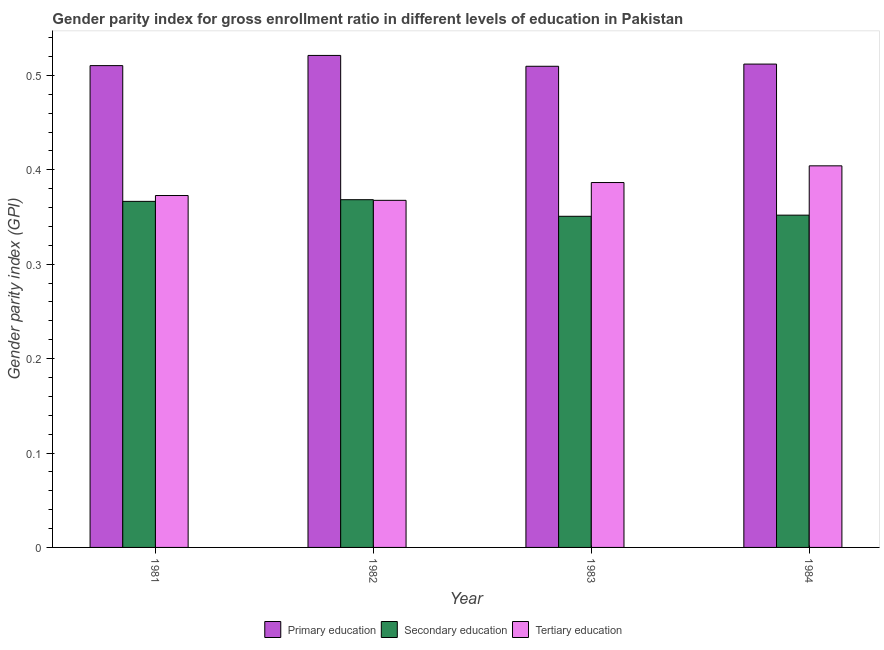What is the gender parity index in tertiary education in 1982?
Ensure brevity in your answer.  0.37. Across all years, what is the maximum gender parity index in secondary education?
Offer a very short reply. 0.37. Across all years, what is the minimum gender parity index in secondary education?
Your response must be concise. 0.35. What is the total gender parity index in primary education in the graph?
Offer a very short reply. 2.05. What is the difference between the gender parity index in secondary education in 1981 and that in 1982?
Make the answer very short. -0. What is the difference between the gender parity index in primary education in 1983 and the gender parity index in tertiary education in 1984?
Give a very brief answer. -0. What is the average gender parity index in tertiary education per year?
Your answer should be very brief. 0.38. In the year 1982, what is the difference between the gender parity index in tertiary education and gender parity index in primary education?
Your answer should be very brief. 0. In how many years, is the gender parity index in secondary education greater than 0.24000000000000002?
Provide a succinct answer. 4. What is the ratio of the gender parity index in primary education in 1981 to that in 1983?
Make the answer very short. 1. Is the difference between the gender parity index in tertiary education in 1983 and 1984 greater than the difference between the gender parity index in primary education in 1983 and 1984?
Keep it short and to the point. No. What is the difference between the highest and the second highest gender parity index in tertiary education?
Your answer should be very brief. 0.02. What is the difference between the highest and the lowest gender parity index in primary education?
Your response must be concise. 0.01. What does the 2nd bar from the left in 1981 represents?
Ensure brevity in your answer.  Secondary education. What does the 2nd bar from the right in 1982 represents?
Give a very brief answer. Secondary education. Are all the bars in the graph horizontal?
Your answer should be very brief. No. Does the graph contain any zero values?
Provide a short and direct response. No. Does the graph contain grids?
Make the answer very short. No. Where does the legend appear in the graph?
Provide a succinct answer. Bottom center. How many legend labels are there?
Your answer should be compact. 3. What is the title of the graph?
Give a very brief answer. Gender parity index for gross enrollment ratio in different levels of education in Pakistan. Does "Transport services" appear as one of the legend labels in the graph?
Keep it short and to the point. No. What is the label or title of the X-axis?
Your answer should be compact. Year. What is the label or title of the Y-axis?
Offer a terse response. Gender parity index (GPI). What is the Gender parity index (GPI) in Primary education in 1981?
Give a very brief answer. 0.51. What is the Gender parity index (GPI) in Secondary education in 1981?
Keep it short and to the point. 0.37. What is the Gender parity index (GPI) of Tertiary education in 1981?
Offer a terse response. 0.37. What is the Gender parity index (GPI) in Primary education in 1982?
Your answer should be very brief. 0.52. What is the Gender parity index (GPI) of Secondary education in 1982?
Your answer should be compact. 0.37. What is the Gender parity index (GPI) in Tertiary education in 1982?
Ensure brevity in your answer.  0.37. What is the Gender parity index (GPI) in Primary education in 1983?
Make the answer very short. 0.51. What is the Gender parity index (GPI) in Secondary education in 1983?
Keep it short and to the point. 0.35. What is the Gender parity index (GPI) of Tertiary education in 1983?
Offer a terse response. 0.39. What is the Gender parity index (GPI) of Primary education in 1984?
Ensure brevity in your answer.  0.51. What is the Gender parity index (GPI) in Secondary education in 1984?
Make the answer very short. 0.35. What is the Gender parity index (GPI) in Tertiary education in 1984?
Keep it short and to the point. 0.4. Across all years, what is the maximum Gender parity index (GPI) in Primary education?
Give a very brief answer. 0.52. Across all years, what is the maximum Gender parity index (GPI) of Secondary education?
Provide a succinct answer. 0.37. Across all years, what is the maximum Gender parity index (GPI) in Tertiary education?
Offer a terse response. 0.4. Across all years, what is the minimum Gender parity index (GPI) of Primary education?
Make the answer very short. 0.51. Across all years, what is the minimum Gender parity index (GPI) in Secondary education?
Your answer should be compact. 0.35. Across all years, what is the minimum Gender parity index (GPI) in Tertiary education?
Offer a terse response. 0.37. What is the total Gender parity index (GPI) of Primary education in the graph?
Your answer should be very brief. 2.05. What is the total Gender parity index (GPI) of Secondary education in the graph?
Your response must be concise. 1.44. What is the total Gender parity index (GPI) of Tertiary education in the graph?
Provide a short and direct response. 1.53. What is the difference between the Gender parity index (GPI) in Primary education in 1981 and that in 1982?
Your answer should be compact. -0.01. What is the difference between the Gender parity index (GPI) in Secondary education in 1981 and that in 1982?
Make the answer very short. -0. What is the difference between the Gender parity index (GPI) in Tertiary education in 1981 and that in 1982?
Give a very brief answer. 0.01. What is the difference between the Gender parity index (GPI) of Primary education in 1981 and that in 1983?
Ensure brevity in your answer.  0. What is the difference between the Gender parity index (GPI) of Secondary education in 1981 and that in 1983?
Make the answer very short. 0.02. What is the difference between the Gender parity index (GPI) of Tertiary education in 1981 and that in 1983?
Make the answer very short. -0.01. What is the difference between the Gender parity index (GPI) of Primary education in 1981 and that in 1984?
Ensure brevity in your answer.  -0. What is the difference between the Gender parity index (GPI) of Secondary education in 1981 and that in 1984?
Your answer should be very brief. 0.01. What is the difference between the Gender parity index (GPI) of Tertiary education in 1981 and that in 1984?
Give a very brief answer. -0.03. What is the difference between the Gender parity index (GPI) in Primary education in 1982 and that in 1983?
Make the answer very short. 0.01. What is the difference between the Gender parity index (GPI) in Secondary education in 1982 and that in 1983?
Provide a short and direct response. 0.02. What is the difference between the Gender parity index (GPI) in Tertiary education in 1982 and that in 1983?
Make the answer very short. -0.02. What is the difference between the Gender parity index (GPI) of Primary education in 1982 and that in 1984?
Ensure brevity in your answer.  0.01. What is the difference between the Gender parity index (GPI) in Secondary education in 1982 and that in 1984?
Offer a very short reply. 0.02. What is the difference between the Gender parity index (GPI) of Tertiary education in 1982 and that in 1984?
Ensure brevity in your answer.  -0.04. What is the difference between the Gender parity index (GPI) in Primary education in 1983 and that in 1984?
Offer a very short reply. -0. What is the difference between the Gender parity index (GPI) of Secondary education in 1983 and that in 1984?
Make the answer very short. -0. What is the difference between the Gender parity index (GPI) of Tertiary education in 1983 and that in 1984?
Provide a short and direct response. -0.02. What is the difference between the Gender parity index (GPI) of Primary education in 1981 and the Gender parity index (GPI) of Secondary education in 1982?
Provide a short and direct response. 0.14. What is the difference between the Gender parity index (GPI) of Primary education in 1981 and the Gender parity index (GPI) of Tertiary education in 1982?
Provide a short and direct response. 0.14. What is the difference between the Gender parity index (GPI) in Secondary education in 1981 and the Gender parity index (GPI) in Tertiary education in 1982?
Provide a succinct answer. -0. What is the difference between the Gender parity index (GPI) in Primary education in 1981 and the Gender parity index (GPI) in Secondary education in 1983?
Provide a short and direct response. 0.16. What is the difference between the Gender parity index (GPI) in Primary education in 1981 and the Gender parity index (GPI) in Tertiary education in 1983?
Offer a very short reply. 0.12. What is the difference between the Gender parity index (GPI) in Secondary education in 1981 and the Gender parity index (GPI) in Tertiary education in 1983?
Keep it short and to the point. -0.02. What is the difference between the Gender parity index (GPI) of Primary education in 1981 and the Gender parity index (GPI) of Secondary education in 1984?
Offer a terse response. 0.16. What is the difference between the Gender parity index (GPI) of Primary education in 1981 and the Gender parity index (GPI) of Tertiary education in 1984?
Offer a very short reply. 0.11. What is the difference between the Gender parity index (GPI) of Secondary education in 1981 and the Gender parity index (GPI) of Tertiary education in 1984?
Keep it short and to the point. -0.04. What is the difference between the Gender parity index (GPI) in Primary education in 1982 and the Gender parity index (GPI) in Secondary education in 1983?
Your response must be concise. 0.17. What is the difference between the Gender parity index (GPI) of Primary education in 1982 and the Gender parity index (GPI) of Tertiary education in 1983?
Give a very brief answer. 0.13. What is the difference between the Gender parity index (GPI) of Secondary education in 1982 and the Gender parity index (GPI) of Tertiary education in 1983?
Give a very brief answer. -0.02. What is the difference between the Gender parity index (GPI) in Primary education in 1982 and the Gender parity index (GPI) in Secondary education in 1984?
Your response must be concise. 0.17. What is the difference between the Gender parity index (GPI) of Primary education in 1982 and the Gender parity index (GPI) of Tertiary education in 1984?
Provide a short and direct response. 0.12. What is the difference between the Gender parity index (GPI) in Secondary education in 1982 and the Gender parity index (GPI) in Tertiary education in 1984?
Give a very brief answer. -0.04. What is the difference between the Gender parity index (GPI) in Primary education in 1983 and the Gender parity index (GPI) in Secondary education in 1984?
Provide a short and direct response. 0.16. What is the difference between the Gender parity index (GPI) in Primary education in 1983 and the Gender parity index (GPI) in Tertiary education in 1984?
Your response must be concise. 0.11. What is the difference between the Gender parity index (GPI) in Secondary education in 1983 and the Gender parity index (GPI) in Tertiary education in 1984?
Your response must be concise. -0.05. What is the average Gender parity index (GPI) of Primary education per year?
Keep it short and to the point. 0.51. What is the average Gender parity index (GPI) in Secondary education per year?
Provide a succinct answer. 0.36. What is the average Gender parity index (GPI) in Tertiary education per year?
Your answer should be compact. 0.38. In the year 1981, what is the difference between the Gender parity index (GPI) in Primary education and Gender parity index (GPI) in Secondary education?
Your answer should be very brief. 0.14. In the year 1981, what is the difference between the Gender parity index (GPI) of Primary education and Gender parity index (GPI) of Tertiary education?
Provide a short and direct response. 0.14. In the year 1981, what is the difference between the Gender parity index (GPI) in Secondary education and Gender parity index (GPI) in Tertiary education?
Offer a terse response. -0.01. In the year 1982, what is the difference between the Gender parity index (GPI) in Primary education and Gender parity index (GPI) in Secondary education?
Make the answer very short. 0.15. In the year 1982, what is the difference between the Gender parity index (GPI) of Primary education and Gender parity index (GPI) of Tertiary education?
Make the answer very short. 0.15. In the year 1982, what is the difference between the Gender parity index (GPI) in Secondary education and Gender parity index (GPI) in Tertiary education?
Provide a succinct answer. 0. In the year 1983, what is the difference between the Gender parity index (GPI) in Primary education and Gender parity index (GPI) in Secondary education?
Offer a very short reply. 0.16. In the year 1983, what is the difference between the Gender parity index (GPI) in Primary education and Gender parity index (GPI) in Tertiary education?
Make the answer very short. 0.12. In the year 1983, what is the difference between the Gender parity index (GPI) of Secondary education and Gender parity index (GPI) of Tertiary education?
Your answer should be compact. -0.04. In the year 1984, what is the difference between the Gender parity index (GPI) in Primary education and Gender parity index (GPI) in Secondary education?
Provide a succinct answer. 0.16. In the year 1984, what is the difference between the Gender parity index (GPI) of Primary education and Gender parity index (GPI) of Tertiary education?
Make the answer very short. 0.11. In the year 1984, what is the difference between the Gender parity index (GPI) in Secondary education and Gender parity index (GPI) in Tertiary education?
Your answer should be compact. -0.05. What is the ratio of the Gender parity index (GPI) in Primary education in 1981 to that in 1982?
Your answer should be very brief. 0.98. What is the ratio of the Gender parity index (GPI) in Secondary education in 1981 to that in 1982?
Provide a succinct answer. 1. What is the ratio of the Gender parity index (GPI) of Tertiary education in 1981 to that in 1982?
Offer a very short reply. 1.01. What is the ratio of the Gender parity index (GPI) of Primary education in 1981 to that in 1983?
Make the answer very short. 1. What is the ratio of the Gender parity index (GPI) of Secondary education in 1981 to that in 1983?
Provide a succinct answer. 1.04. What is the ratio of the Gender parity index (GPI) of Tertiary education in 1981 to that in 1983?
Your response must be concise. 0.96. What is the ratio of the Gender parity index (GPI) of Primary education in 1981 to that in 1984?
Make the answer very short. 1. What is the ratio of the Gender parity index (GPI) of Secondary education in 1981 to that in 1984?
Offer a terse response. 1.04. What is the ratio of the Gender parity index (GPI) of Tertiary education in 1981 to that in 1984?
Give a very brief answer. 0.92. What is the ratio of the Gender parity index (GPI) of Primary education in 1982 to that in 1983?
Keep it short and to the point. 1.02. What is the ratio of the Gender parity index (GPI) of Secondary education in 1982 to that in 1983?
Provide a succinct answer. 1.05. What is the ratio of the Gender parity index (GPI) of Tertiary education in 1982 to that in 1983?
Your answer should be very brief. 0.95. What is the ratio of the Gender parity index (GPI) in Primary education in 1982 to that in 1984?
Keep it short and to the point. 1.02. What is the ratio of the Gender parity index (GPI) in Secondary education in 1982 to that in 1984?
Keep it short and to the point. 1.05. What is the ratio of the Gender parity index (GPI) in Tertiary education in 1982 to that in 1984?
Your answer should be very brief. 0.91. What is the ratio of the Gender parity index (GPI) of Primary education in 1983 to that in 1984?
Keep it short and to the point. 1. What is the ratio of the Gender parity index (GPI) in Secondary education in 1983 to that in 1984?
Provide a succinct answer. 1. What is the ratio of the Gender parity index (GPI) of Tertiary education in 1983 to that in 1984?
Give a very brief answer. 0.96. What is the difference between the highest and the second highest Gender parity index (GPI) of Primary education?
Your answer should be compact. 0.01. What is the difference between the highest and the second highest Gender parity index (GPI) of Secondary education?
Make the answer very short. 0. What is the difference between the highest and the second highest Gender parity index (GPI) of Tertiary education?
Offer a terse response. 0.02. What is the difference between the highest and the lowest Gender parity index (GPI) in Primary education?
Provide a short and direct response. 0.01. What is the difference between the highest and the lowest Gender parity index (GPI) in Secondary education?
Keep it short and to the point. 0.02. What is the difference between the highest and the lowest Gender parity index (GPI) in Tertiary education?
Give a very brief answer. 0.04. 